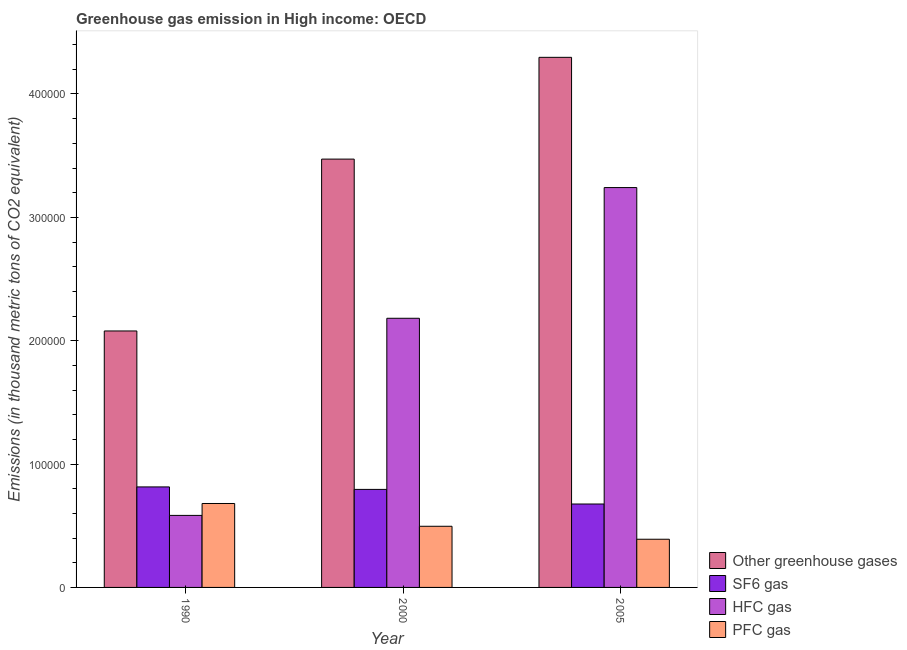How many different coloured bars are there?
Your answer should be compact. 4. How many groups of bars are there?
Provide a short and direct response. 3. Are the number of bars on each tick of the X-axis equal?
Offer a terse response. Yes. How many bars are there on the 3rd tick from the right?
Your response must be concise. 4. What is the label of the 1st group of bars from the left?
Provide a short and direct response. 1990. In how many cases, is the number of bars for a given year not equal to the number of legend labels?
Your answer should be very brief. 0. What is the emission of hfc gas in 1990?
Provide a succinct answer. 5.84e+04. Across all years, what is the maximum emission of pfc gas?
Offer a very short reply. 6.80e+04. Across all years, what is the minimum emission of pfc gas?
Give a very brief answer. 3.91e+04. In which year was the emission of sf6 gas minimum?
Provide a succinct answer. 2005. What is the total emission of hfc gas in the graph?
Your answer should be compact. 6.01e+05. What is the difference between the emission of pfc gas in 2000 and that in 2005?
Your response must be concise. 1.05e+04. What is the difference between the emission of pfc gas in 2005 and the emission of greenhouse gases in 2000?
Provide a short and direct response. -1.05e+04. What is the average emission of sf6 gas per year?
Provide a succinct answer. 7.62e+04. In the year 1990, what is the difference between the emission of hfc gas and emission of pfc gas?
Give a very brief answer. 0. What is the ratio of the emission of hfc gas in 2000 to that in 2005?
Your answer should be very brief. 0.67. Is the emission of sf6 gas in 1990 less than that in 2005?
Your answer should be very brief. No. What is the difference between the highest and the second highest emission of pfc gas?
Provide a succinct answer. 1.85e+04. What is the difference between the highest and the lowest emission of hfc gas?
Make the answer very short. 2.66e+05. In how many years, is the emission of pfc gas greater than the average emission of pfc gas taken over all years?
Provide a succinct answer. 1. Is the sum of the emission of pfc gas in 1990 and 2005 greater than the maximum emission of sf6 gas across all years?
Give a very brief answer. Yes. Is it the case that in every year, the sum of the emission of greenhouse gases and emission of hfc gas is greater than the sum of emission of sf6 gas and emission of pfc gas?
Give a very brief answer. Yes. What does the 2nd bar from the left in 2000 represents?
Ensure brevity in your answer.  SF6 gas. What does the 1st bar from the right in 1990 represents?
Make the answer very short. PFC gas. Are all the bars in the graph horizontal?
Give a very brief answer. No. How many years are there in the graph?
Keep it short and to the point. 3. What is the difference between two consecutive major ticks on the Y-axis?
Make the answer very short. 1.00e+05. How many legend labels are there?
Offer a very short reply. 4. How are the legend labels stacked?
Your answer should be compact. Vertical. What is the title of the graph?
Your answer should be very brief. Greenhouse gas emission in High income: OECD. Does "International Development Association" appear as one of the legend labels in the graph?
Your answer should be compact. No. What is the label or title of the Y-axis?
Offer a terse response. Emissions (in thousand metric tons of CO2 equivalent). What is the Emissions (in thousand metric tons of CO2 equivalent) in Other greenhouse gases in 1990?
Give a very brief answer. 2.08e+05. What is the Emissions (in thousand metric tons of CO2 equivalent) in SF6 gas in 1990?
Make the answer very short. 8.15e+04. What is the Emissions (in thousand metric tons of CO2 equivalent) in HFC gas in 1990?
Ensure brevity in your answer.  5.84e+04. What is the Emissions (in thousand metric tons of CO2 equivalent) of PFC gas in 1990?
Make the answer very short. 6.80e+04. What is the Emissions (in thousand metric tons of CO2 equivalent) in Other greenhouse gases in 2000?
Your response must be concise. 3.47e+05. What is the Emissions (in thousand metric tons of CO2 equivalent) in SF6 gas in 2000?
Offer a terse response. 7.95e+04. What is the Emissions (in thousand metric tons of CO2 equivalent) of HFC gas in 2000?
Your response must be concise. 2.18e+05. What is the Emissions (in thousand metric tons of CO2 equivalent) of PFC gas in 2000?
Your answer should be very brief. 4.96e+04. What is the Emissions (in thousand metric tons of CO2 equivalent) of Other greenhouse gases in 2005?
Your answer should be compact. 4.30e+05. What is the Emissions (in thousand metric tons of CO2 equivalent) of SF6 gas in 2005?
Offer a very short reply. 6.76e+04. What is the Emissions (in thousand metric tons of CO2 equivalent) of HFC gas in 2005?
Your response must be concise. 3.24e+05. What is the Emissions (in thousand metric tons of CO2 equivalent) in PFC gas in 2005?
Make the answer very short. 3.91e+04. Across all years, what is the maximum Emissions (in thousand metric tons of CO2 equivalent) in Other greenhouse gases?
Ensure brevity in your answer.  4.30e+05. Across all years, what is the maximum Emissions (in thousand metric tons of CO2 equivalent) in SF6 gas?
Keep it short and to the point. 8.15e+04. Across all years, what is the maximum Emissions (in thousand metric tons of CO2 equivalent) of HFC gas?
Provide a succinct answer. 3.24e+05. Across all years, what is the maximum Emissions (in thousand metric tons of CO2 equivalent) of PFC gas?
Ensure brevity in your answer.  6.80e+04. Across all years, what is the minimum Emissions (in thousand metric tons of CO2 equivalent) in Other greenhouse gases?
Your answer should be very brief. 2.08e+05. Across all years, what is the minimum Emissions (in thousand metric tons of CO2 equivalent) in SF6 gas?
Your answer should be very brief. 6.76e+04. Across all years, what is the minimum Emissions (in thousand metric tons of CO2 equivalent) of HFC gas?
Make the answer very short. 5.84e+04. Across all years, what is the minimum Emissions (in thousand metric tons of CO2 equivalent) in PFC gas?
Provide a short and direct response. 3.91e+04. What is the total Emissions (in thousand metric tons of CO2 equivalent) in Other greenhouse gases in the graph?
Ensure brevity in your answer.  9.85e+05. What is the total Emissions (in thousand metric tons of CO2 equivalent) in SF6 gas in the graph?
Provide a succinct answer. 2.29e+05. What is the total Emissions (in thousand metric tons of CO2 equivalent) in HFC gas in the graph?
Keep it short and to the point. 6.01e+05. What is the total Emissions (in thousand metric tons of CO2 equivalent) of PFC gas in the graph?
Ensure brevity in your answer.  1.57e+05. What is the difference between the Emissions (in thousand metric tons of CO2 equivalent) in Other greenhouse gases in 1990 and that in 2000?
Give a very brief answer. -1.39e+05. What is the difference between the Emissions (in thousand metric tons of CO2 equivalent) in SF6 gas in 1990 and that in 2000?
Offer a very short reply. 2011.1. What is the difference between the Emissions (in thousand metric tons of CO2 equivalent) in HFC gas in 1990 and that in 2000?
Your response must be concise. -1.60e+05. What is the difference between the Emissions (in thousand metric tons of CO2 equivalent) in PFC gas in 1990 and that in 2000?
Your answer should be very brief. 1.85e+04. What is the difference between the Emissions (in thousand metric tons of CO2 equivalent) in Other greenhouse gases in 1990 and that in 2005?
Make the answer very short. -2.22e+05. What is the difference between the Emissions (in thousand metric tons of CO2 equivalent) of SF6 gas in 1990 and that in 2005?
Ensure brevity in your answer.  1.39e+04. What is the difference between the Emissions (in thousand metric tons of CO2 equivalent) of HFC gas in 1990 and that in 2005?
Keep it short and to the point. -2.66e+05. What is the difference between the Emissions (in thousand metric tons of CO2 equivalent) of PFC gas in 1990 and that in 2005?
Provide a succinct answer. 2.90e+04. What is the difference between the Emissions (in thousand metric tons of CO2 equivalent) in Other greenhouse gases in 2000 and that in 2005?
Your answer should be compact. -8.25e+04. What is the difference between the Emissions (in thousand metric tons of CO2 equivalent) in SF6 gas in 2000 and that in 2005?
Your answer should be very brief. 1.18e+04. What is the difference between the Emissions (in thousand metric tons of CO2 equivalent) in HFC gas in 2000 and that in 2005?
Offer a very short reply. -1.06e+05. What is the difference between the Emissions (in thousand metric tons of CO2 equivalent) in PFC gas in 2000 and that in 2005?
Make the answer very short. 1.05e+04. What is the difference between the Emissions (in thousand metric tons of CO2 equivalent) of Other greenhouse gases in 1990 and the Emissions (in thousand metric tons of CO2 equivalent) of SF6 gas in 2000?
Provide a short and direct response. 1.28e+05. What is the difference between the Emissions (in thousand metric tons of CO2 equivalent) in Other greenhouse gases in 1990 and the Emissions (in thousand metric tons of CO2 equivalent) in HFC gas in 2000?
Keep it short and to the point. -1.03e+04. What is the difference between the Emissions (in thousand metric tons of CO2 equivalent) in Other greenhouse gases in 1990 and the Emissions (in thousand metric tons of CO2 equivalent) in PFC gas in 2000?
Your answer should be very brief. 1.58e+05. What is the difference between the Emissions (in thousand metric tons of CO2 equivalent) of SF6 gas in 1990 and the Emissions (in thousand metric tons of CO2 equivalent) of HFC gas in 2000?
Your answer should be very brief. -1.37e+05. What is the difference between the Emissions (in thousand metric tons of CO2 equivalent) of SF6 gas in 1990 and the Emissions (in thousand metric tons of CO2 equivalent) of PFC gas in 2000?
Provide a short and direct response. 3.19e+04. What is the difference between the Emissions (in thousand metric tons of CO2 equivalent) of HFC gas in 1990 and the Emissions (in thousand metric tons of CO2 equivalent) of PFC gas in 2000?
Make the answer very short. 8816.3. What is the difference between the Emissions (in thousand metric tons of CO2 equivalent) in Other greenhouse gases in 1990 and the Emissions (in thousand metric tons of CO2 equivalent) in SF6 gas in 2005?
Provide a succinct answer. 1.40e+05. What is the difference between the Emissions (in thousand metric tons of CO2 equivalent) of Other greenhouse gases in 1990 and the Emissions (in thousand metric tons of CO2 equivalent) of HFC gas in 2005?
Offer a terse response. -1.16e+05. What is the difference between the Emissions (in thousand metric tons of CO2 equivalent) of Other greenhouse gases in 1990 and the Emissions (in thousand metric tons of CO2 equivalent) of PFC gas in 2005?
Make the answer very short. 1.69e+05. What is the difference between the Emissions (in thousand metric tons of CO2 equivalent) of SF6 gas in 1990 and the Emissions (in thousand metric tons of CO2 equivalent) of HFC gas in 2005?
Your answer should be very brief. -2.43e+05. What is the difference between the Emissions (in thousand metric tons of CO2 equivalent) of SF6 gas in 1990 and the Emissions (in thousand metric tons of CO2 equivalent) of PFC gas in 2005?
Keep it short and to the point. 4.24e+04. What is the difference between the Emissions (in thousand metric tons of CO2 equivalent) in HFC gas in 1990 and the Emissions (in thousand metric tons of CO2 equivalent) in PFC gas in 2005?
Offer a terse response. 1.93e+04. What is the difference between the Emissions (in thousand metric tons of CO2 equivalent) in Other greenhouse gases in 2000 and the Emissions (in thousand metric tons of CO2 equivalent) in SF6 gas in 2005?
Ensure brevity in your answer.  2.80e+05. What is the difference between the Emissions (in thousand metric tons of CO2 equivalent) of Other greenhouse gases in 2000 and the Emissions (in thousand metric tons of CO2 equivalent) of HFC gas in 2005?
Offer a very short reply. 2.31e+04. What is the difference between the Emissions (in thousand metric tons of CO2 equivalent) of Other greenhouse gases in 2000 and the Emissions (in thousand metric tons of CO2 equivalent) of PFC gas in 2005?
Offer a very short reply. 3.08e+05. What is the difference between the Emissions (in thousand metric tons of CO2 equivalent) of SF6 gas in 2000 and the Emissions (in thousand metric tons of CO2 equivalent) of HFC gas in 2005?
Provide a succinct answer. -2.45e+05. What is the difference between the Emissions (in thousand metric tons of CO2 equivalent) of SF6 gas in 2000 and the Emissions (in thousand metric tons of CO2 equivalent) of PFC gas in 2005?
Your response must be concise. 4.04e+04. What is the difference between the Emissions (in thousand metric tons of CO2 equivalent) of HFC gas in 2000 and the Emissions (in thousand metric tons of CO2 equivalent) of PFC gas in 2005?
Your answer should be compact. 1.79e+05. What is the average Emissions (in thousand metric tons of CO2 equivalent) in Other greenhouse gases per year?
Your response must be concise. 3.28e+05. What is the average Emissions (in thousand metric tons of CO2 equivalent) in SF6 gas per year?
Offer a very short reply. 7.62e+04. What is the average Emissions (in thousand metric tons of CO2 equivalent) in HFC gas per year?
Your answer should be very brief. 2.00e+05. What is the average Emissions (in thousand metric tons of CO2 equivalent) of PFC gas per year?
Provide a succinct answer. 5.22e+04. In the year 1990, what is the difference between the Emissions (in thousand metric tons of CO2 equivalent) of Other greenhouse gases and Emissions (in thousand metric tons of CO2 equivalent) of SF6 gas?
Make the answer very short. 1.26e+05. In the year 1990, what is the difference between the Emissions (in thousand metric tons of CO2 equivalent) in Other greenhouse gases and Emissions (in thousand metric tons of CO2 equivalent) in HFC gas?
Keep it short and to the point. 1.50e+05. In the year 1990, what is the difference between the Emissions (in thousand metric tons of CO2 equivalent) in Other greenhouse gases and Emissions (in thousand metric tons of CO2 equivalent) in PFC gas?
Provide a short and direct response. 1.40e+05. In the year 1990, what is the difference between the Emissions (in thousand metric tons of CO2 equivalent) in SF6 gas and Emissions (in thousand metric tons of CO2 equivalent) in HFC gas?
Ensure brevity in your answer.  2.31e+04. In the year 1990, what is the difference between the Emissions (in thousand metric tons of CO2 equivalent) of SF6 gas and Emissions (in thousand metric tons of CO2 equivalent) of PFC gas?
Make the answer very short. 1.34e+04. In the year 1990, what is the difference between the Emissions (in thousand metric tons of CO2 equivalent) in HFC gas and Emissions (in thousand metric tons of CO2 equivalent) in PFC gas?
Your response must be concise. -9648.1. In the year 2000, what is the difference between the Emissions (in thousand metric tons of CO2 equivalent) of Other greenhouse gases and Emissions (in thousand metric tons of CO2 equivalent) of SF6 gas?
Offer a terse response. 2.68e+05. In the year 2000, what is the difference between the Emissions (in thousand metric tons of CO2 equivalent) in Other greenhouse gases and Emissions (in thousand metric tons of CO2 equivalent) in HFC gas?
Your answer should be compact. 1.29e+05. In the year 2000, what is the difference between the Emissions (in thousand metric tons of CO2 equivalent) in Other greenhouse gases and Emissions (in thousand metric tons of CO2 equivalent) in PFC gas?
Your answer should be very brief. 2.98e+05. In the year 2000, what is the difference between the Emissions (in thousand metric tons of CO2 equivalent) of SF6 gas and Emissions (in thousand metric tons of CO2 equivalent) of HFC gas?
Ensure brevity in your answer.  -1.39e+05. In the year 2000, what is the difference between the Emissions (in thousand metric tons of CO2 equivalent) in SF6 gas and Emissions (in thousand metric tons of CO2 equivalent) in PFC gas?
Give a very brief answer. 2.99e+04. In the year 2000, what is the difference between the Emissions (in thousand metric tons of CO2 equivalent) in HFC gas and Emissions (in thousand metric tons of CO2 equivalent) in PFC gas?
Your answer should be very brief. 1.69e+05. In the year 2005, what is the difference between the Emissions (in thousand metric tons of CO2 equivalent) in Other greenhouse gases and Emissions (in thousand metric tons of CO2 equivalent) in SF6 gas?
Keep it short and to the point. 3.62e+05. In the year 2005, what is the difference between the Emissions (in thousand metric tons of CO2 equivalent) of Other greenhouse gases and Emissions (in thousand metric tons of CO2 equivalent) of HFC gas?
Provide a succinct answer. 1.06e+05. In the year 2005, what is the difference between the Emissions (in thousand metric tons of CO2 equivalent) in Other greenhouse gases and Emissions (in thousand metric tons of CO2 equivalent) in PFC gas?
Make the answer very short. 3.91e+05. In the year 2005, what is the difference between the Emissions (in thousand metric tons of CO2 equivalent) in SF6 gas and Emissions (in thousand metric tons of CO2 equivalent) in HFC gas?
Offer a very short reply. -2.57e+05. In the year 2005, what is the difference between the Emissions (in thousand metric tons of CO2 equivalent) in SF6 gas and Emissions (in thousand metric tons of CO2 equivalent) in PFC gas?
Your answer should be compact. 2.86e+04. In the year 2005, what is the difference between the Emissions (in thousand metric tons of CO2 equivalent) in HFC gas and Emissions (in thousand metric tons of CO2 equivalent) in PFC gas?
Your response must be concise. 2.85e+05. What is the ratio of the Emissions (in thousand metric tons of CO2 equivalent) of Other greenhouse gases in 1990 to that in 2000?
Your answer should be very brief. 0.6. What is the ratio of the Emissions (in thousand metric tons of CO2 equivalent) in SF6 gas in 1990 to that in 2000?
Offer a very short reply. 1.03. What is the ratio of the Emissions (in thousand metric tons of CO2 equivalent) in HFC gas in 1990 to that in 2000?
Make the answer very short. 0.27. What is the ratio of the Emissions (in thousand metric tons of CO2 equivalent) in PFC gas in 1990 to that in 2000?
Ensure brevity in your answer.  1.37. What is the ratio of the Emissions (in thousand metric tons of CO2 equivalent) in Other greenhouse gases in 1990 to that in 2005?
Make the answer very short. 0.48. What is the ratio of the Emissions (in thousand metric tons of CO2 equivalent) in SF6 gas in 1990 to that in 2005?
Provide a succinct answer. 1.2. What is the ratio of the Emissions (in thousand metric tons of CO2 equivalent) of HFC gas in 1990 to that in 2005?
Offer a very short reply. 0.18. What is the ratio of the Emissions (in thousand metric tons of CO2 equivalent) of PFC gas in 1990 to that in 2005?
Provide a short and direct response. 1.74. What is the ratio of the Emissions (in thousand metric tons of CO2 equivalent) in Other greenhouse gases in 2000 to that in 2005?
Make the answer very short. 0.81. What is the ratio of the Emissions (in thousand metric tons of CO2 equivalent) of SF6 gas in 2000 to that in 2005?
Offer a very short reply. 1.18. What is the ratio of the Emissions (in thousand metric tons of CO2 equivalent) in HFC gas in 2000 to that in 2005?
Give a very brief answer. 0.67. What is the ratio of the Emissions (in thousand metric tons of CO2 equivalent) in PFC gas in 2000 to that in 2005?
Your answer should be very brief. 1.27. What is the difference between the highest and the second highest Emissions (in thousand metric tons of CO2 equivalent) of Other greenhouse gases?
Make the answer very short. 8.25e+04. What is the difference between the highest and the second highest Emissions (in thousand metric tons of CO2 equivalent) in SF6 gas?
Make the answer very short. 2011.1. What is the difference between the highest and the second highest Emissions (in thousand metric tons of CO2 equivalent) of HFC gas?
Ensure brevity in your answer.  1.06e+05. What is the difference between the highest and the second highest Emissions (in thousand metric tons of CO2 equivalent) in PFC gas?
Give a very brief answer. 1.85e+04. What is the difference between the highest and the lowest Emissions (in thousand metric tons of CO2 equivalent) of Other greenhouse gases?
Make the answer very short. 2.22e+05. What is the difference between the highest and the lowest Emissions (in thousand metric tons of CO2 equivalent) of SF6 gas?
Your answer should be compact. 1.39e+04. What is the difference between the highest and the lowest Emissions (in thousand metric tons of CO2 equivalent) of HFC gas?
Keep it short and to the point. 2.66e+05. What is the difference between the highest and the lowest Emissions (in thousand metric tons of CO2 equivalent) in PFC gas?
Your answer should be very brief. 2.90e+04. 